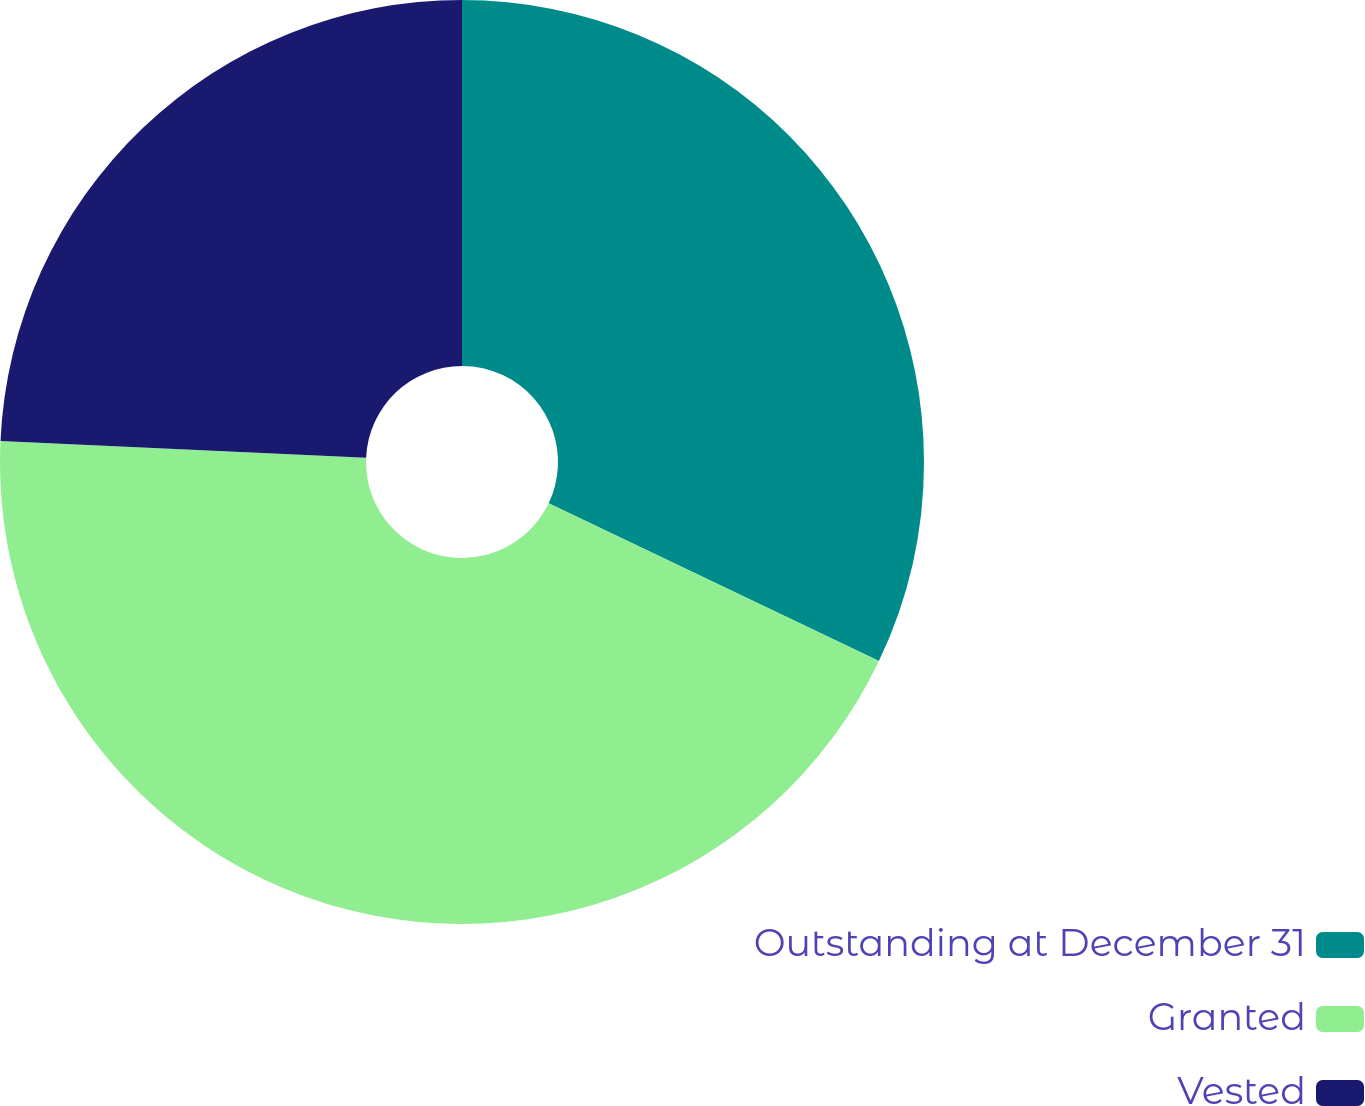Convert chart. <chart><loc_0><loc_0><loc_500><loc_500><pie_chart><fcel>Outstanding at December 31<fcel>Granted<fcel>Vested<nl><fcel>32.09%<fcel>43.63%<fcel>24.28%<nl></chart> 